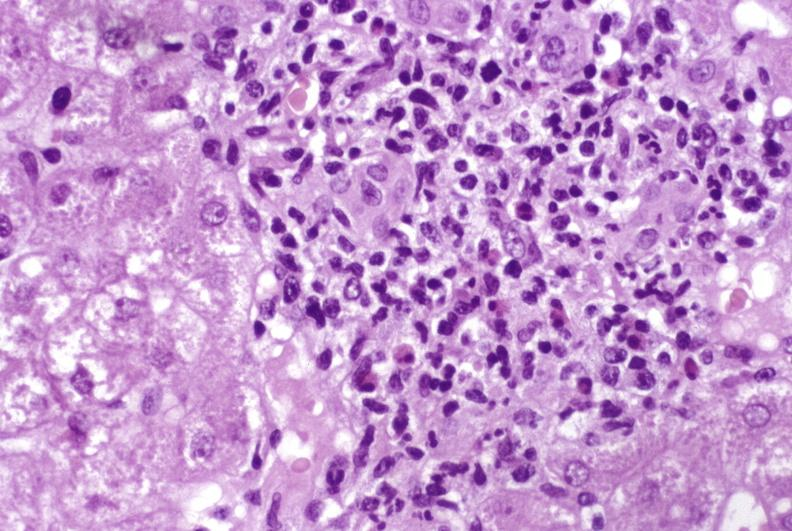what is present?
Answer the question using a single word or phrase. Hepatobiliary 